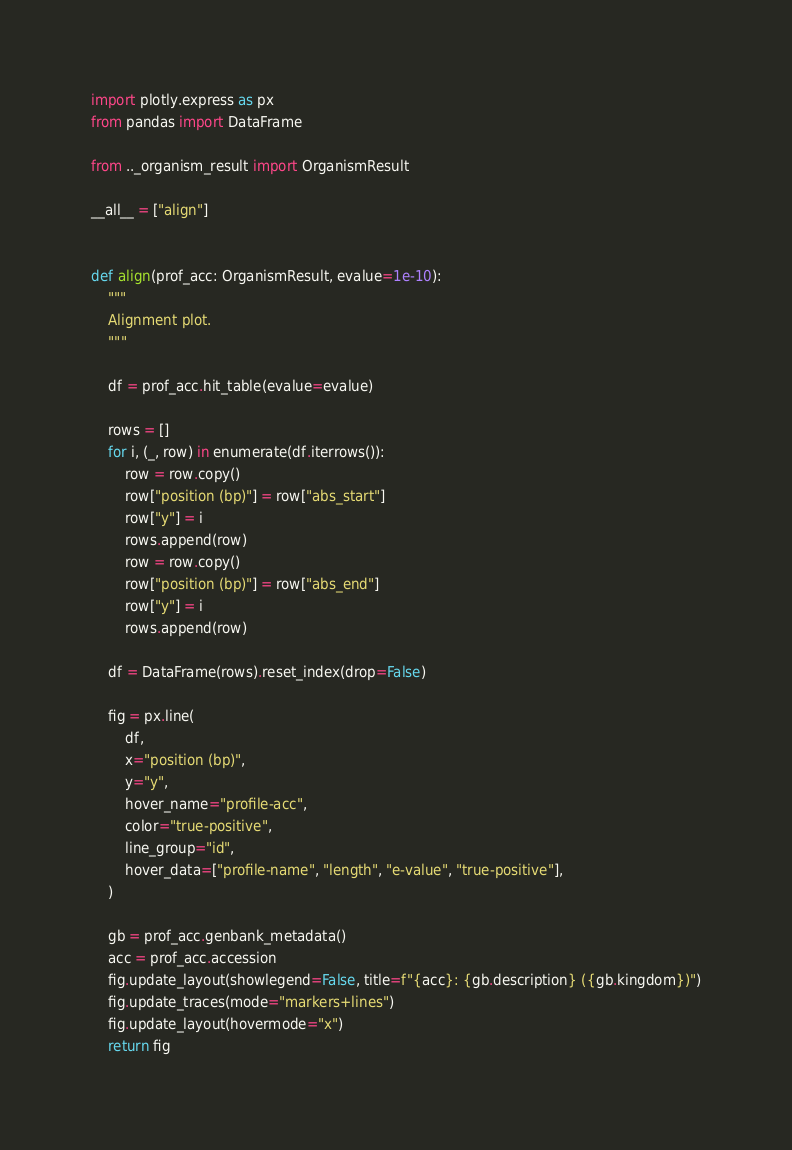<code> <loc_0><loc_0><loc_500><loc_500><_Python_>import plotly.express as px
from pandas import DataFrame

from .._organism_result import OrganismResult

__all__ = ["align"]


def align(prof_acc: OrganismResult, evalue=1e-10):
    """
    Alignment plot.
    """

    df = prof_acc.hit_table(evalue=evalue)

    rows = []
    for i, (_, row) in enumerate(df.iterrows()):
        row = row.copy()
        row["position (bp)"] = row["abs_start"]
        row["y"] = i
        rows.append(row)
        row = row.copy()
        row["position (bp)"] = row["abs_end"]
        row["y"] = i
        rows.append(row)

    df = DataFrame(rows).reset_index(drop=False)

    fig = px.line(
        df,
        x="position (bp)",
        y="y",
        hover_name="profile-acc",
        color="true-positive",
        line_group="id",
        hover_data=["profile-name", "length", "e-value", "true-positive"],
    )

    gb = prof_acc.genbank_metadata()
    acc = prof_acc.accession
    fig.update_layout(showlegend=False, title=f"{acc}: {gb.description} ({gb.kingdom})")
    fig.update_traces(mode="markers+lines")
    fig.update_layout(hovermode="x")
    return fig
</code> 